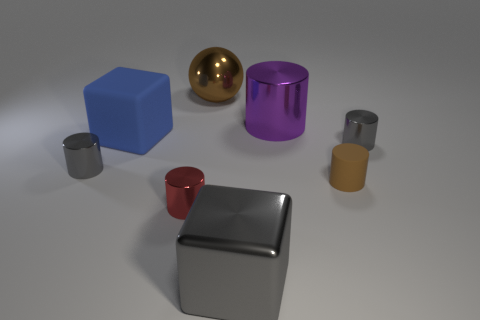Subtract 1 cylinders. How many cylinders are left? 4 Subtract all red shiny cylinders. How many cylinders are left? 4 Subtract all purple cylinders. How many cylinders are left? 4 Subtract all yellow cylinders. Subtract all gray cubes. How many cylinders are left? 5 Add 1 tiny purple objects. How many objects exist? 9 Subtract all spheres. How many objects are left? 7 Subtract 0 cyan spheres. How many objects are left? 8 Subtract all big green metal things. Subtract all big things. How many objects are left? 4 Add 3 brown things. How many brown things are left? 5 Add 2 large gray metallic balls. How many large gray metallic balls exist? 2 